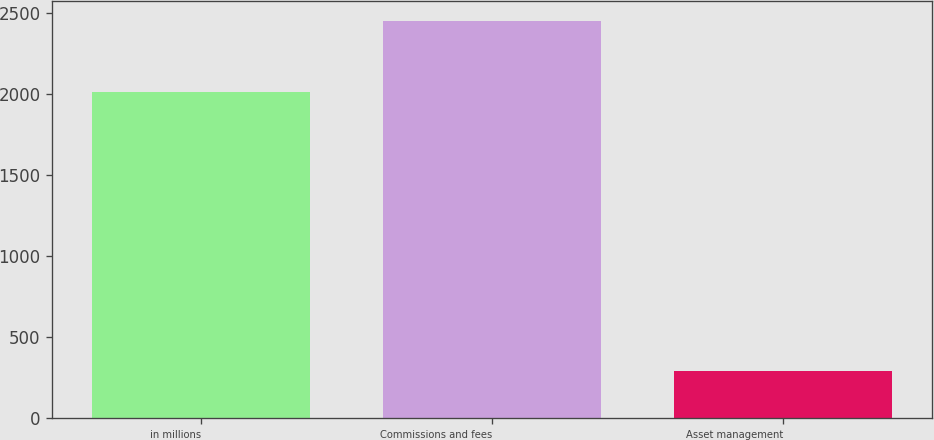<chart> <loc_0><loc_0><loc_500><loc_500><bar_chart><fcel>in millions<fcel>Commissions and fees<fcel>Asset management<nl><fcel>2016<fcel>2456<fcel>293<nl></chart> 